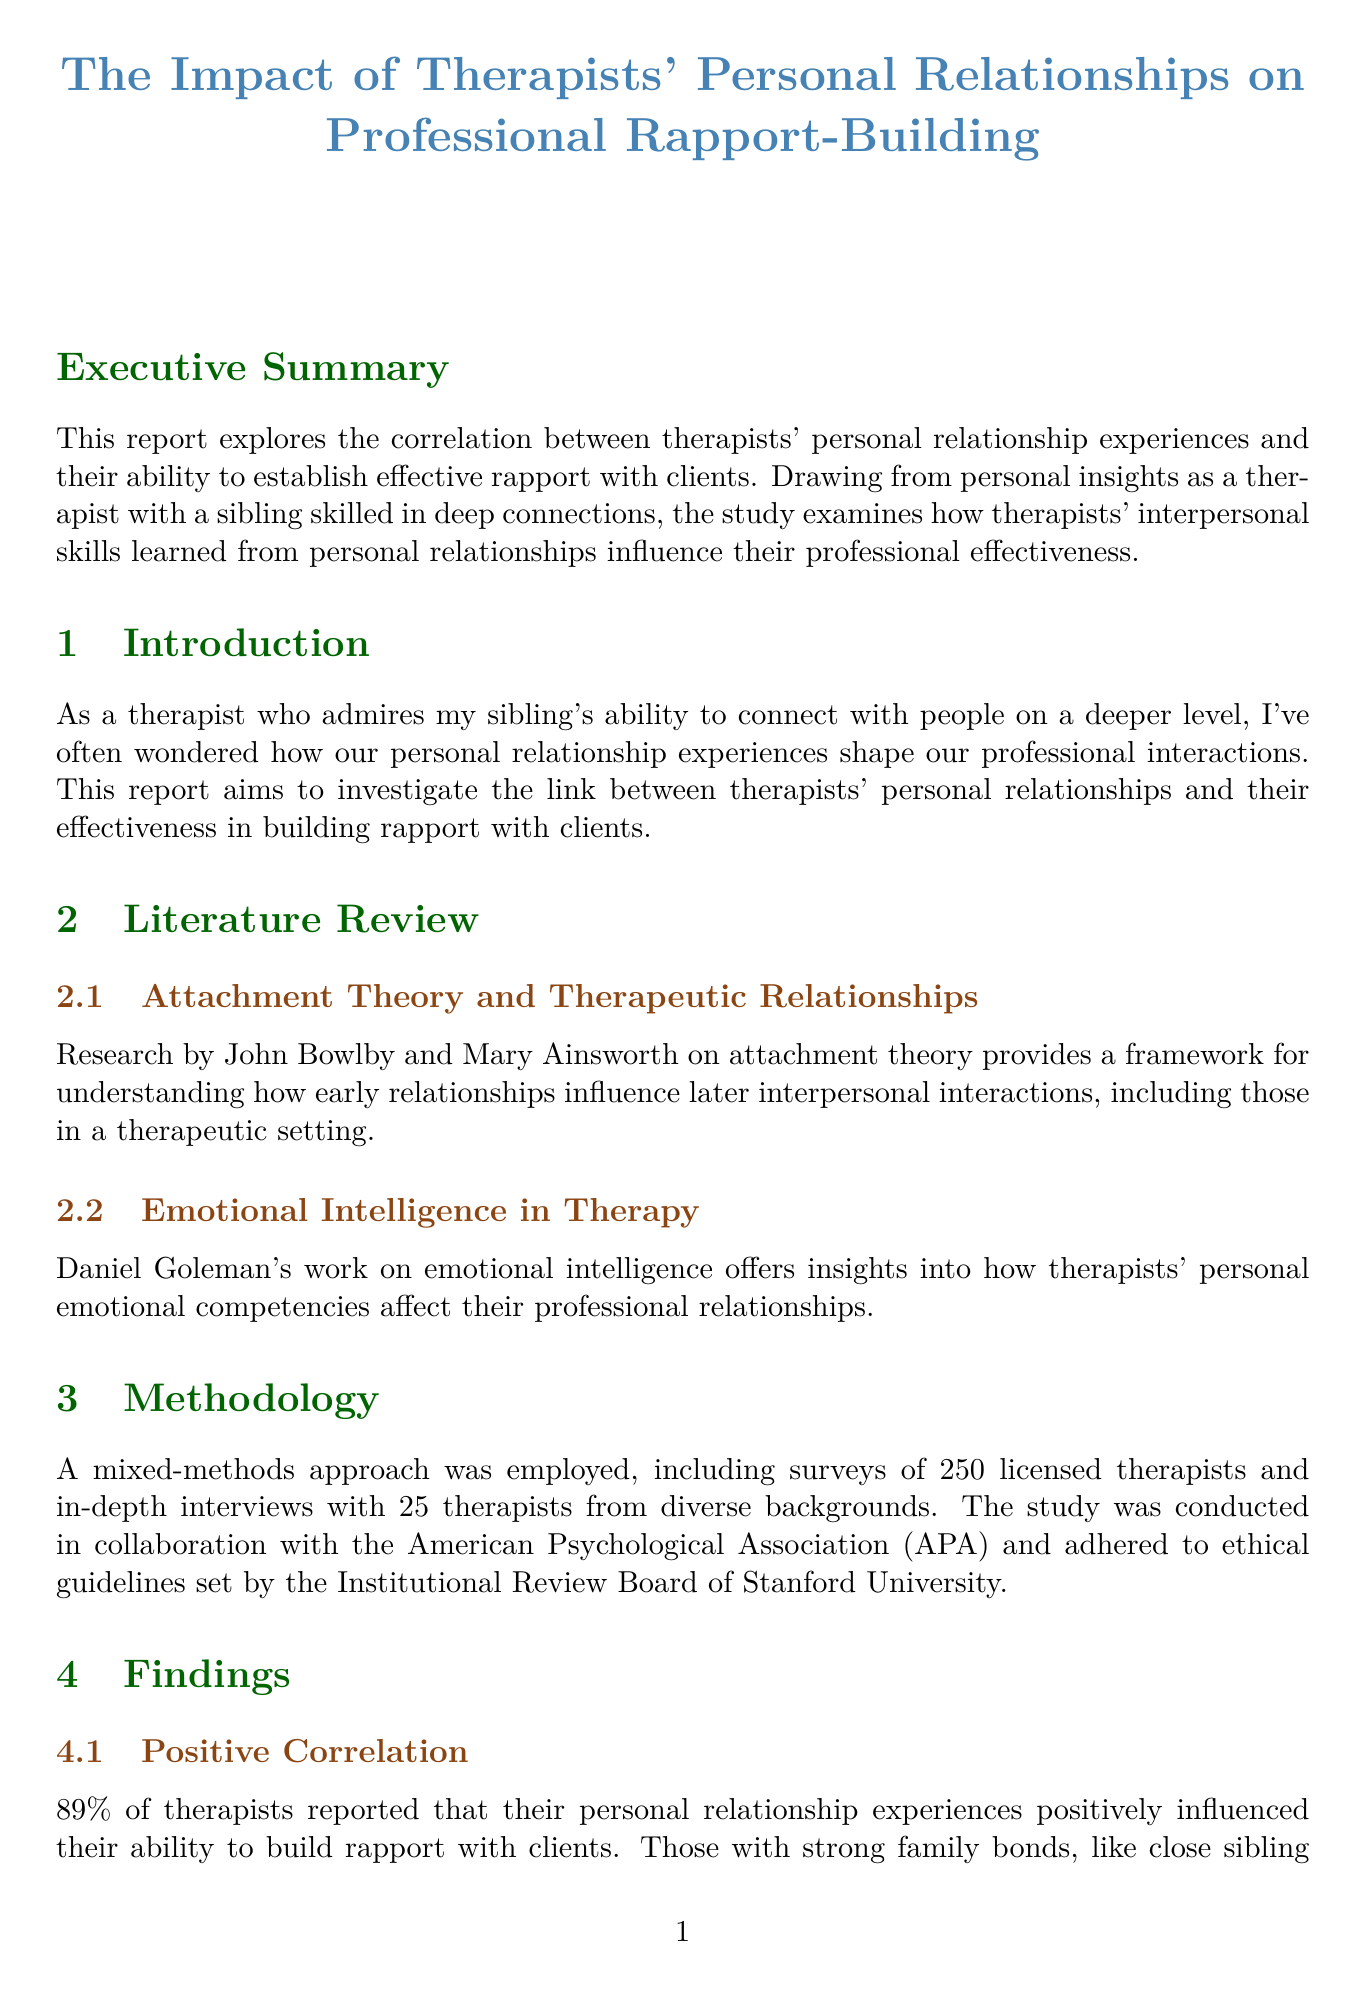What is the report title? The report title is stated at the beginning of the document under the title section.
Answer: The Impact of Therapists' Personal Relationships on Professional Rapport-Building What percentage of therapists reported a positive influence from personal relationships? The document states specific findings regarding the percentage of therapists which indicates how many felt a positive influence in their professional rapport-building.
Answer: 89% Who conducted the study in collaboration with the researchers? The document mentions a specific organization that collaborated with the study, which is significant for the methodology.
Answer: American Psychological Association What is the suggested program for enhancing therapists' interpersonal skills? The report provides a recommendation for a specific program aimed at improving interpersonal skills in therapy education.
Answer: Interpersonal Skills Enhancement Program for Therapists What is one major theoretical framework discussed in the literature review? The literature review discusses important theories that frame the report's findings, focusing on how they relate to therapeutic relationships.
Answer: Attachment Theory What case study is highlighted in the report? The report includes a case study illustrating the impact of personal relationships on professional effectiveness, identifying a specific therapist involved.
Answer: Dr. Sarah Chen What is the primary methodological approach used in the report? The methodology section describes the approach taken for data collection, which is crucial for understanding the research process.
Answer: Mixed-methods What aspect of therapists' experiences is emphasized in the findings? The findings section highlights a specific correlation explored in the context of therapists' personal history and its relevance to their professional practice.
Answer: Personal relationship experiences 